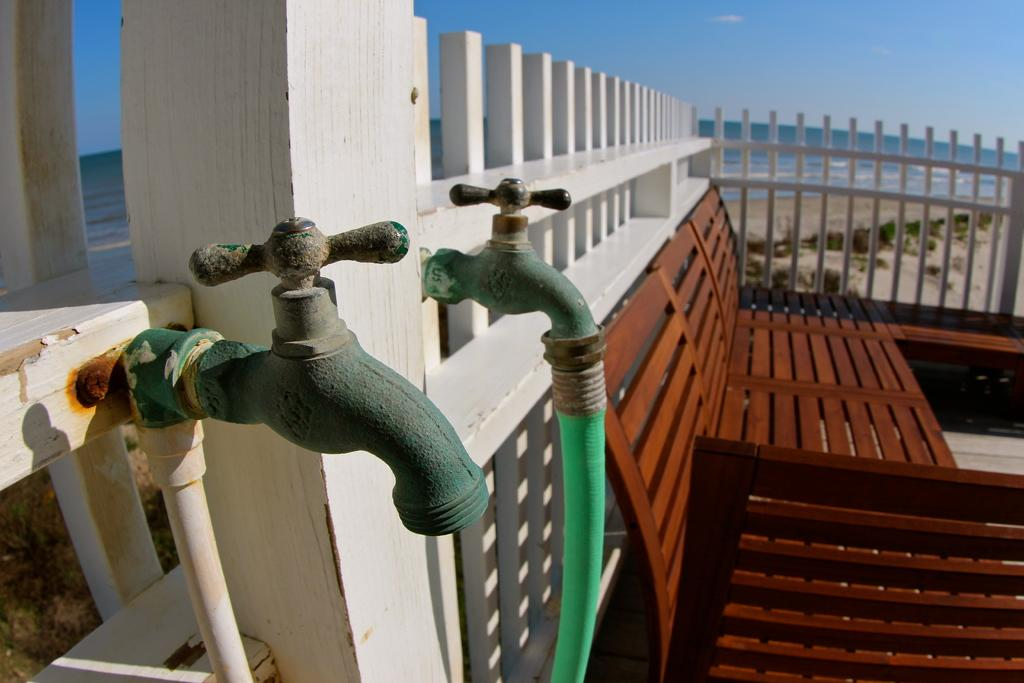How many taps can be seen in the image? There are 2 taps in the image. What is connected to one of the taps? There is a pipe connected to one of the taps. What type of furniture is visible in the image? There are multiple chairs visible in the image. What year is depicted in the image? There is no indication of a specific year in the image. Can you see a pear in the image? There is no pear present in the image. 